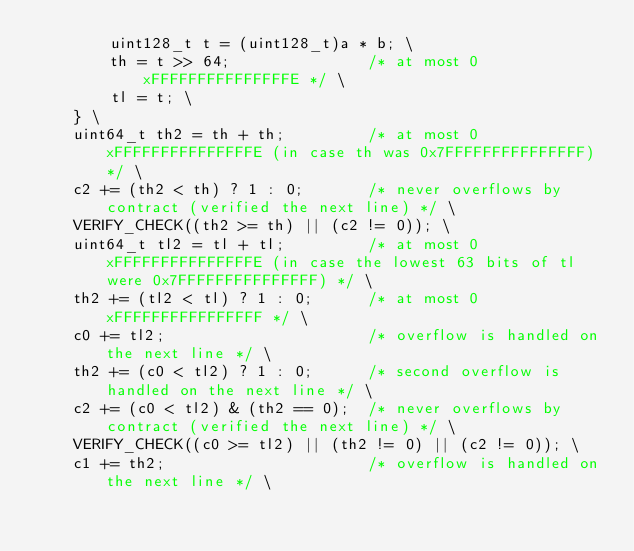Convert code to text. <code><loc_0><loc_0><loc_500><loc_500><_C_>        uint128_t t = (uint128_t)a * b; \
        th = t >> 64;               /* at most 0xFFFFFFFFFFFFFFFE */ \
        tl = t; \
    } \
    uint64_t th2 = th + th;         /* at most 0xFFFFFFFFFFFFFFFE (in case th was 0x7FFFFFFFFFFFFFFF) */ \
    c2 += (th2 < th) ? 1 : 0;       /* never overflows by contract (verified the next line) */ \
    VERIFY_CHECK((th2 >= th) || (c2 != 0)); \
    uint64_t tl2 = tl + tl;         /* at most 0xFFFFFFFFFFFFFFFE (in case the lowest 63 bits of tl were 0x7FFFFFFFFFFFFFFF) */ \
    th2 += (tl2 < tl) ? 1 : 0;      /* at most 0xFFFFFFFFFFFFFFFF */ \
    c0 += tl2;                      /* overflow is handled on the next line */ \
    th2 += (c0 < tl2) ? 1 : 0;      /* second overflow is handled on the next line */ \
    c2 += (c0 < tl2) & (th2 == 0);  /* never overflows by contract (verified the next line) */ \
    VERIFY_CHECK((c0 >= tl2) || (th2 != 0) || (c2 != 0)); \
    c1 += th2;                      /* overflow is handled on the next line */ \</code> 